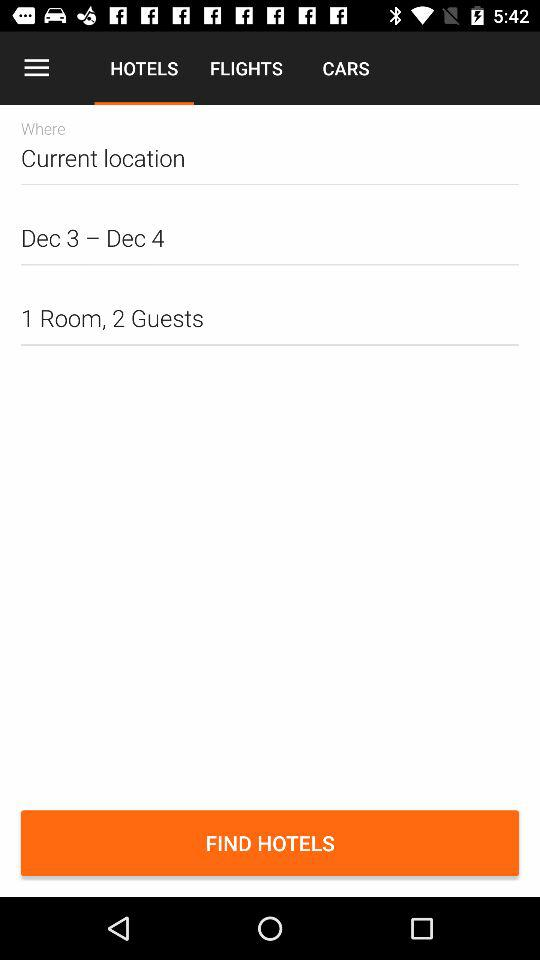What is the selected location? The selected location is "Current location". 